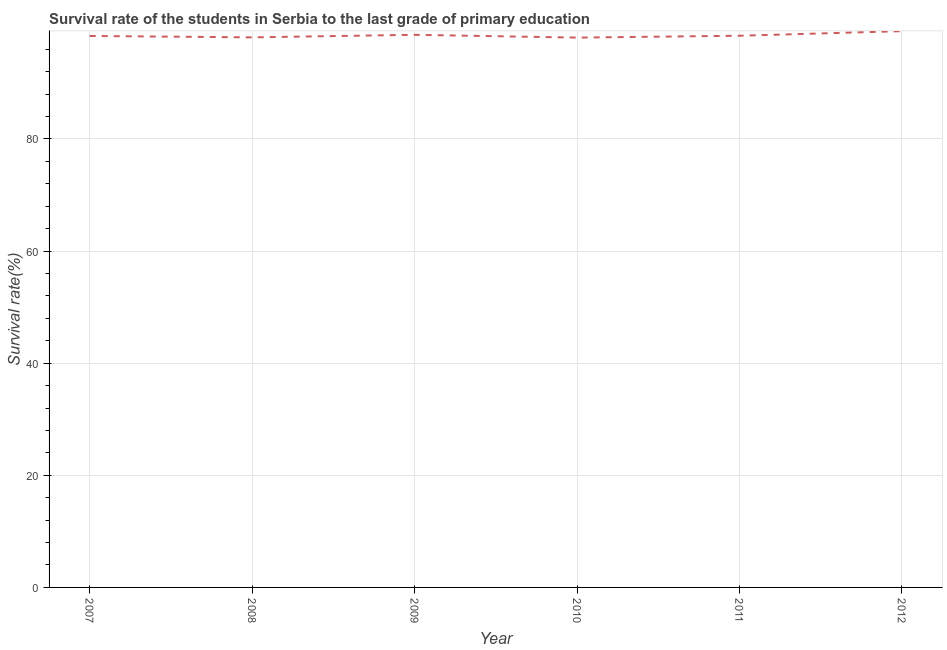What is the survival rate in primary education in 2007?
Offer a very short reply. 98.36. Across all years, what is the maximum survival rate in primary education?
Offer a very short reply. 99.22. Across all years, what is the minimum survival rate in primary education?
Your answer should be very brief. 98.07. In which year was the survival rate in primary education maximum?
Offer a terse response. 2012. What is the sum of the survival rate in primary education?
Make the answer very short. 590.72. What is the difference between the survival rate in primary education in 2007 and 2009?
Ensure brevity in your answer.  -0.2. What is the average survival rate in primary education per year?
Keep it short and to the point. 98.45. What is the median survival rate in primary education?
Give a very brief answer. 98.38. In how many years, is the survival rate in primary education greater than 12 %?
Keep it short and to the point. 6. What is the ratio of the survival rate in primary education in 2007 to that in 2009?
Your answer should be compact. 1. Is the survival rate in primary education in 2008 less than that in 2009?
Offer a very short reply. Yes. Is the difference between the survival rate in primary education in 2010 and 2012 greater than the difference between any two years?
Offer a very short reply. Yes. What is the difference between the highest and the second highest survival rate in primary education?
Make the answer very short. 0.65. What is the difference between the highest and the lowest survival rate in primary education?
Your answer should be compact. 1.15. Does the survival rate in primary education monotonically increase over the years?
Your response must be concise. No. Does the graph contain any zero values?
Provide a short and direct response. No. Does the graph contain grids?
Provide a short and direct response. Yes. What is the title of the graph?
Offer a terse response. Survival rate of the students in Serbia to the last grade of primary education. What is the label or title of the Y-axis?
Give a very brief answer. Survival rate(%). What is the Survival rate(%) of 2007?
Provide a short and direct response. 98.36. What is the Survival rate(%) in 2008?
Offer a terse response. 98.11. What is the Survival rate(%) of 2009?
Offer a very short reply. 98.56. What is the Survival rate(%) of 2010?
Your answer should be very brief. 98.07. What is the Survival rate(%) in 2011?
Make the answer very short. 98.4. What is the Survival rate(%) of 2012?
Ensure brevity in your answer.  99.22. What is the difference between the Survival rate(%) in 2007 and 2008?
Give a very brief answer. 0.25. What is the difference between the Survival rate(%) in 2007 and 2009?
Your answer should be very brief. -0.2. What is the difference between the Survival rate(%) in 2007 and 2010?
Offer a terse response. 0.29. What is the difference between the Survival rate(%) in 2007 and 2011?
Provide a short and direct response. -0.04. What is the difference between the Survival rate(%) in 2007 and 2012?
Offer a terse response. -0.86. What is the difference between the Survival rate(%) in 2008 and 2009?
Your answer should be compact. -0.45. What is the difference between the Survival rate(%) in 2008 and 2010?
Give a very brief answer. 0.04. What is the difference between the Survival rate(%) in 2008 and 2011?
Keep it short and to the point. -0.29. What is the difference between the Survival rate(%) in 2008 and 2012?
Your response must be concise. -1.11. What is the difference between the Survival rate(%) in 2009 and 2010?
Make the answer very short. 0.5. What is the difference between the Survival rate(%) in 2009 and 2011?
Keep it short and to the point. 0.16. What is the difference between the Survival rate(%) in 2009 and 2012?
Provide a succinct answer. -0.65. What is the difference between the Survival rate(%) in 2010 and 2011?
Your response must be concise. -0.33. What is the difference between the Survival rate(%) in 2010 and 2012?
Offer a terse response. -1.15. What is the difference between the Survival rate(%) in 2011 and 2012?
Your response must be concise. -0.82. What is the ratio of the Survival rate(%) in 2007 to that in 2009?
Give a very brief answer. 1. What is the ratio of the Survival rate(%) in 2007 to that in 2011?
Provide a short and direct response. 1. What is the ratio of the Survival rate(%) in 2007 to that in 2012?
Offer a very short reply. 0.99. What is the ratio of the Survival rate(%) in 2008 to that in 2011?
Keep it short and to the point. 1. What is the ratio of the Survival rate(%) in 2009 to that in 2012?
Provide a succinct answer. 0.99. 